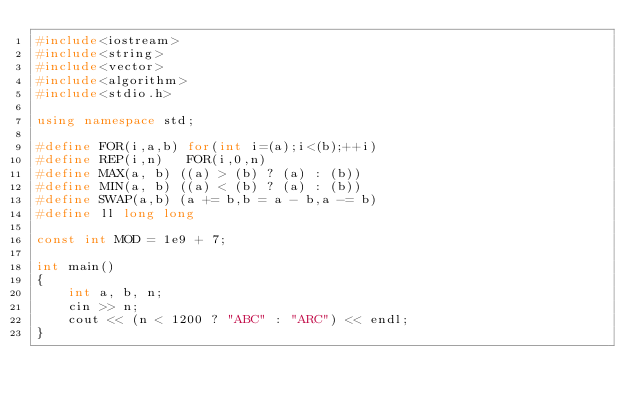<code> <loc_0><loc_0><loc_500><loc_500><_C++_>#include<iostream>
#include<string>
#include<vector>
#include<algorithm>
#include<stdio.h>
 
using namespace std;
 
#define FOR(i,a,b) for(int i=(a);i<(b);++i)
#define REP(i,n)   FOR(i,0,n)
#define MAX(a, b) ((a) > (b) ? (a) : (b))
#define MIN(a, b) ((a) < (b) ? (a) : (b))
#define SWAP(a,b) (a += b,b = a - b,a -= b)
#define ll long long

const int MOD = 1e9 + 7;

int main()
{
    int a, b, n;
    cin >> n;
    cout << (n < 1200 ? "ABC" : "ARC") << endl;
}</code> 